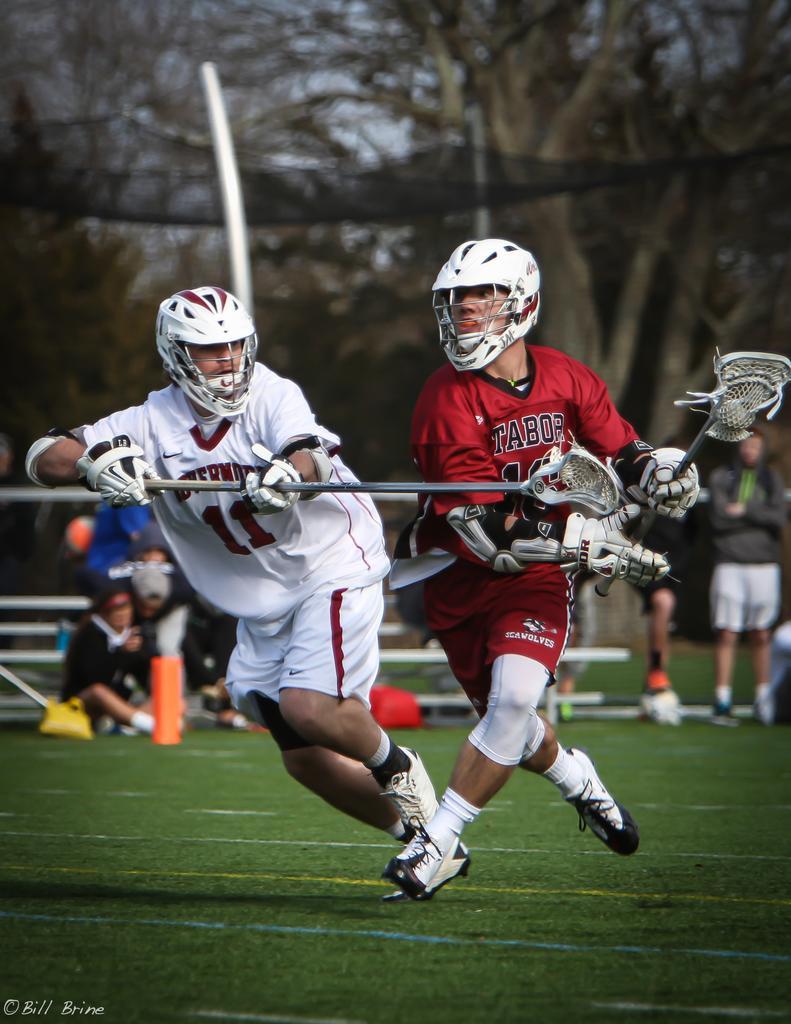How would you summarize this image in a sentence or two? Here in this picture, in the front we can see two persons running in the ground and playing field lacrosse and both of them are wearing gloves and helmet and holding a stick in their hands and we can see the ground is fully covered with grass and we can see number of other people sitting and standing on the ground and we can see plants and trees in blurry manner. 